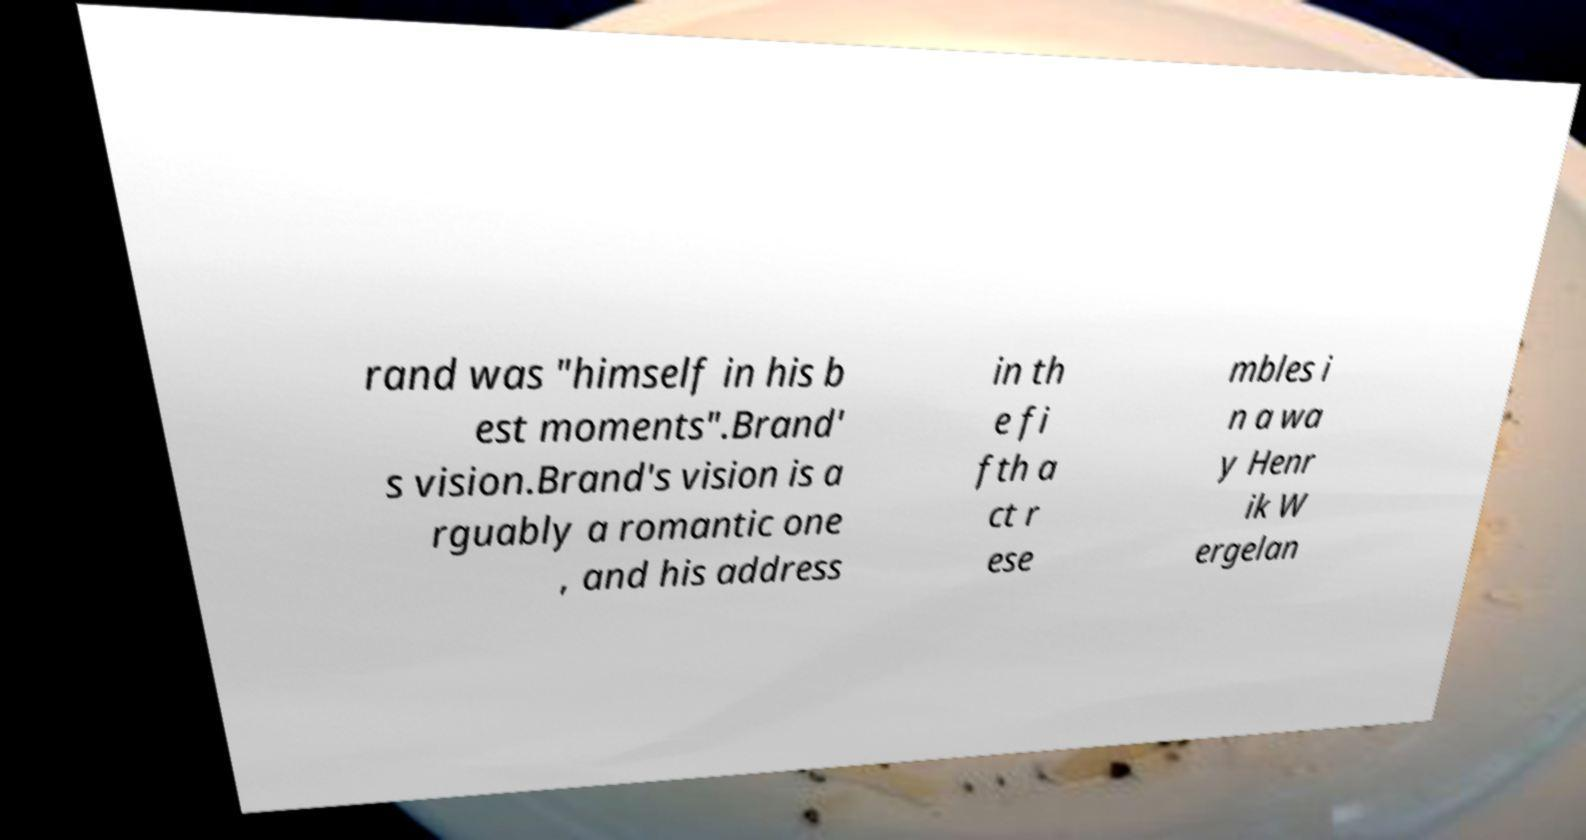There's text embedded in this image that I need extracted. Can you transcribe it verbatim? rand was "himself in his b est moments".Brand' s vision.Brand's vision is a rguably a romantic one , and his address in th e fi fth a ct r ese mbles i n a wa y Henr ik W ergelan 